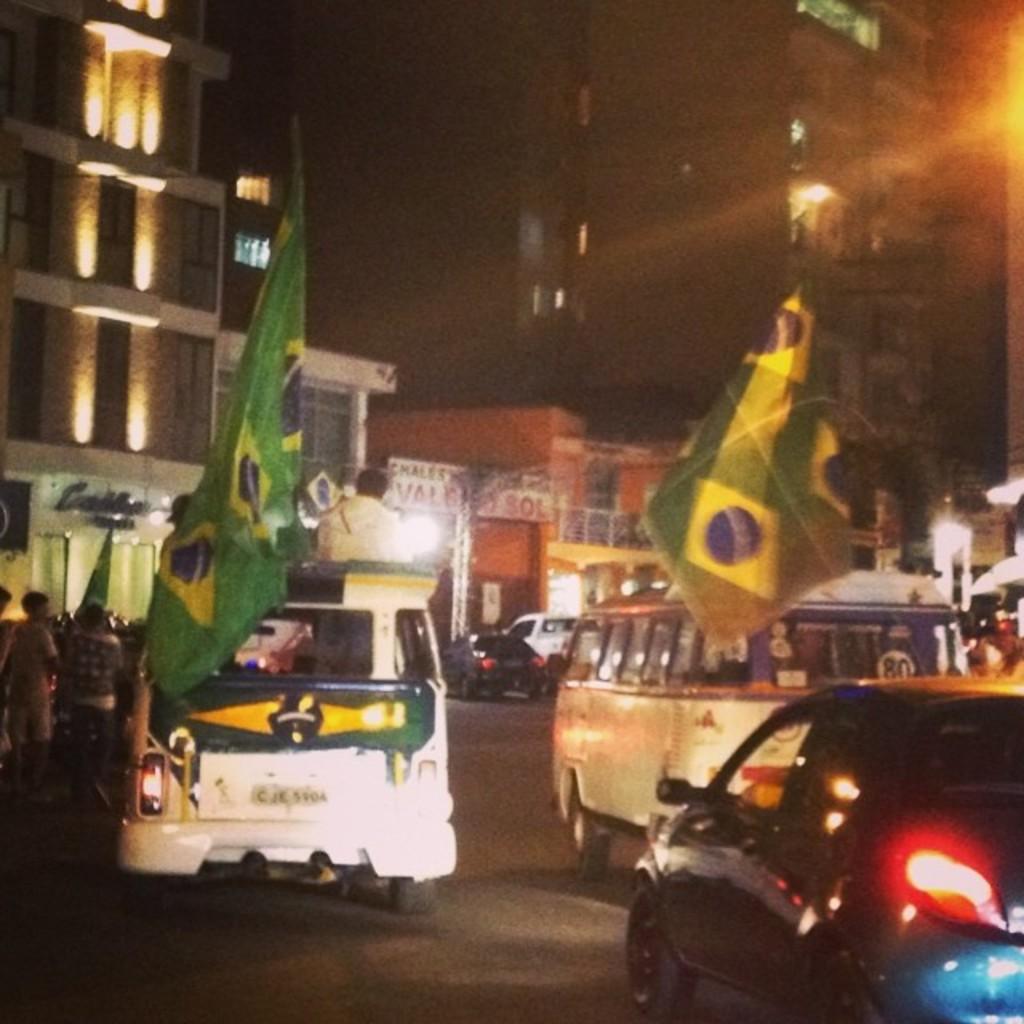What number is written on the back of the bus?
Your answer should be very brief. 80. 